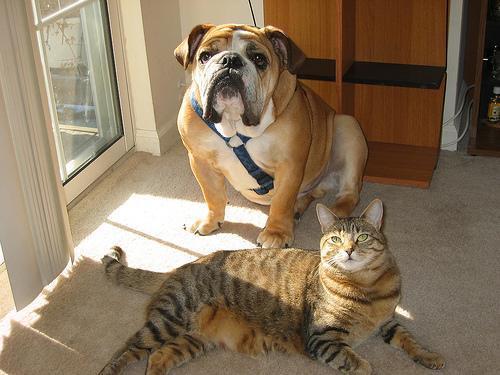How many animals?
Give a very brief answer. 2. 